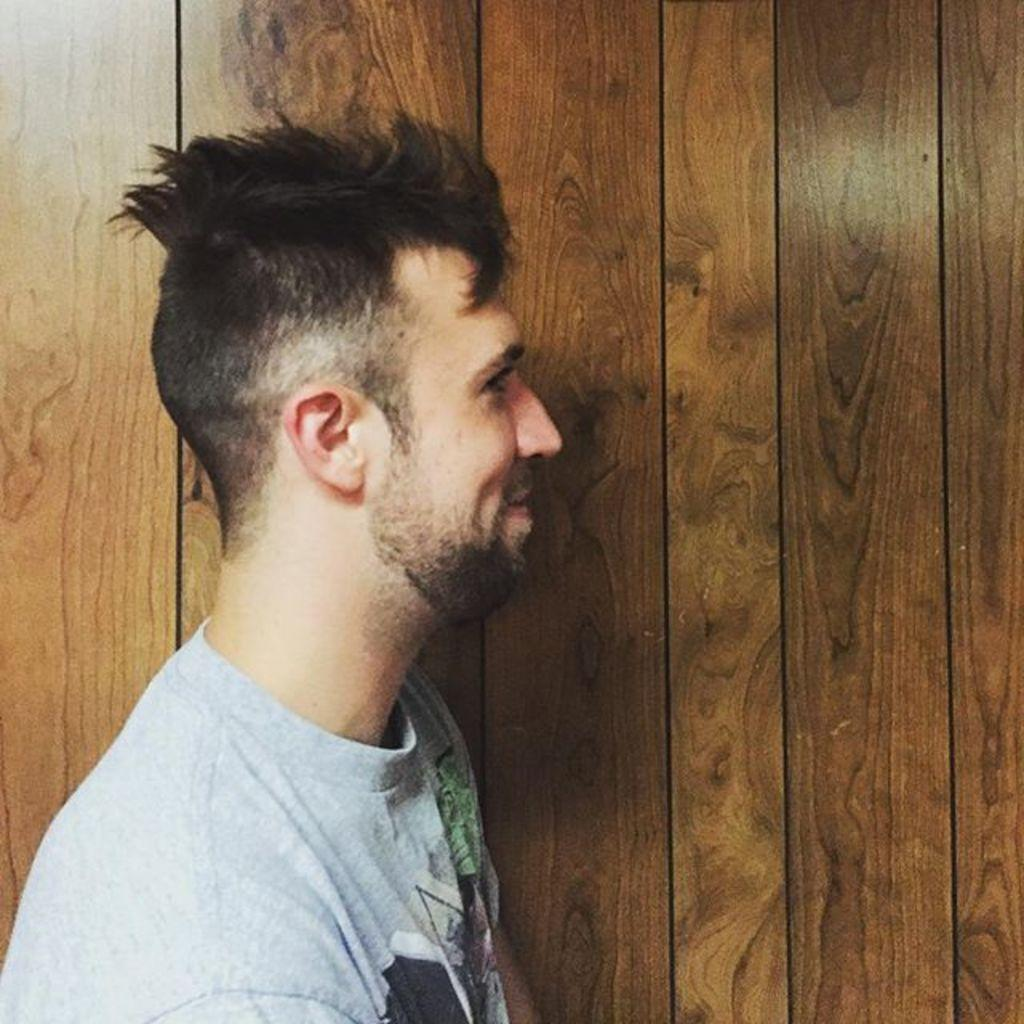What is the main subject of the image? There is a man in the image. What is the man wearing in the image? The man is wearing a t-shirt. What can be seen in the background of the image? There is a wooden wall in the background of the image. What type of rail is visible in the image? There is no rail present in the image. What kind of fuel is being used by the man in the image? The image does not show the man using any fuel. 